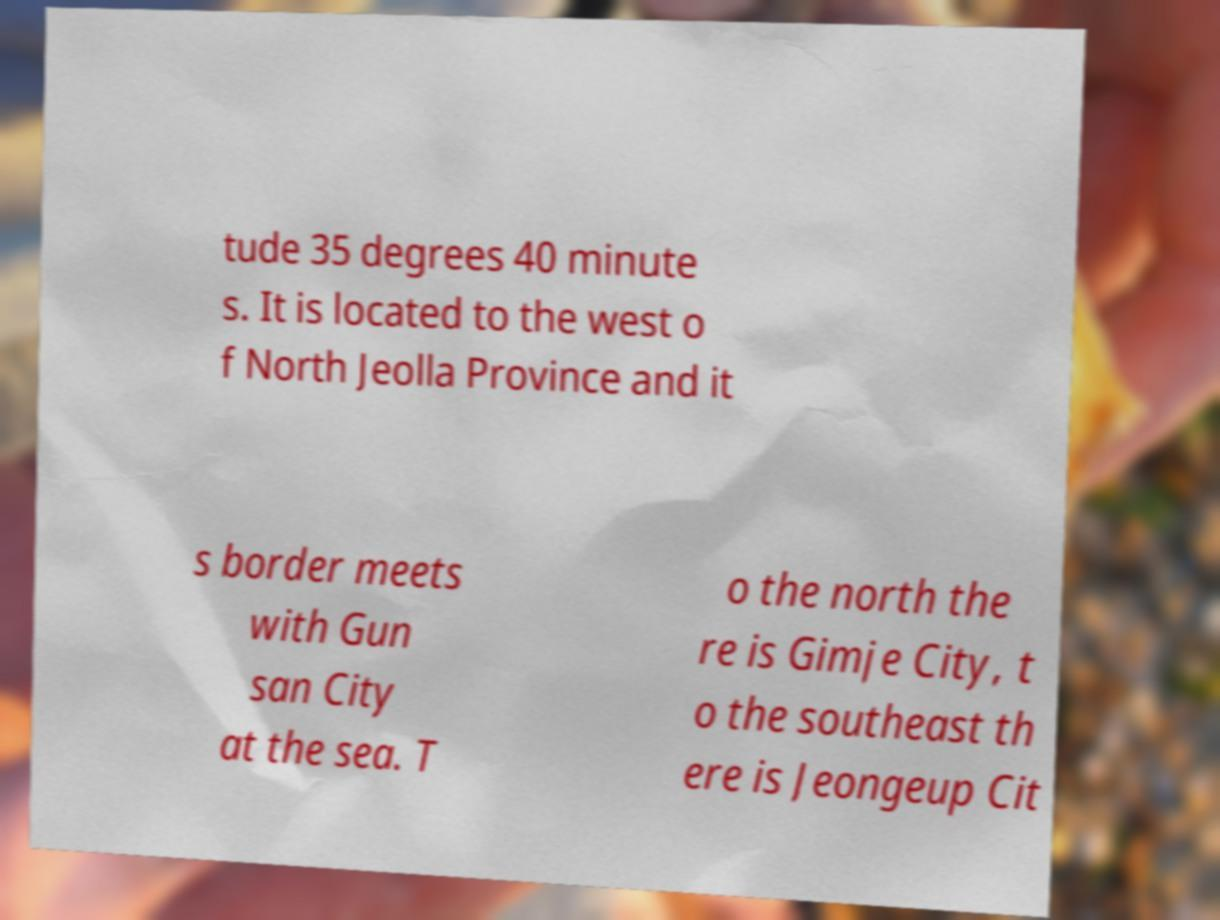For documentation purposes, I need the text within this image transcribed. Could you provide that? tude 35 degrees 40 minute s. It is located to the west o f North Jeolla Province and it s border meets with Gun san City at the sea. T o the north the re is Gimje City, t o the southeast th ere is Jeongeup Cit 